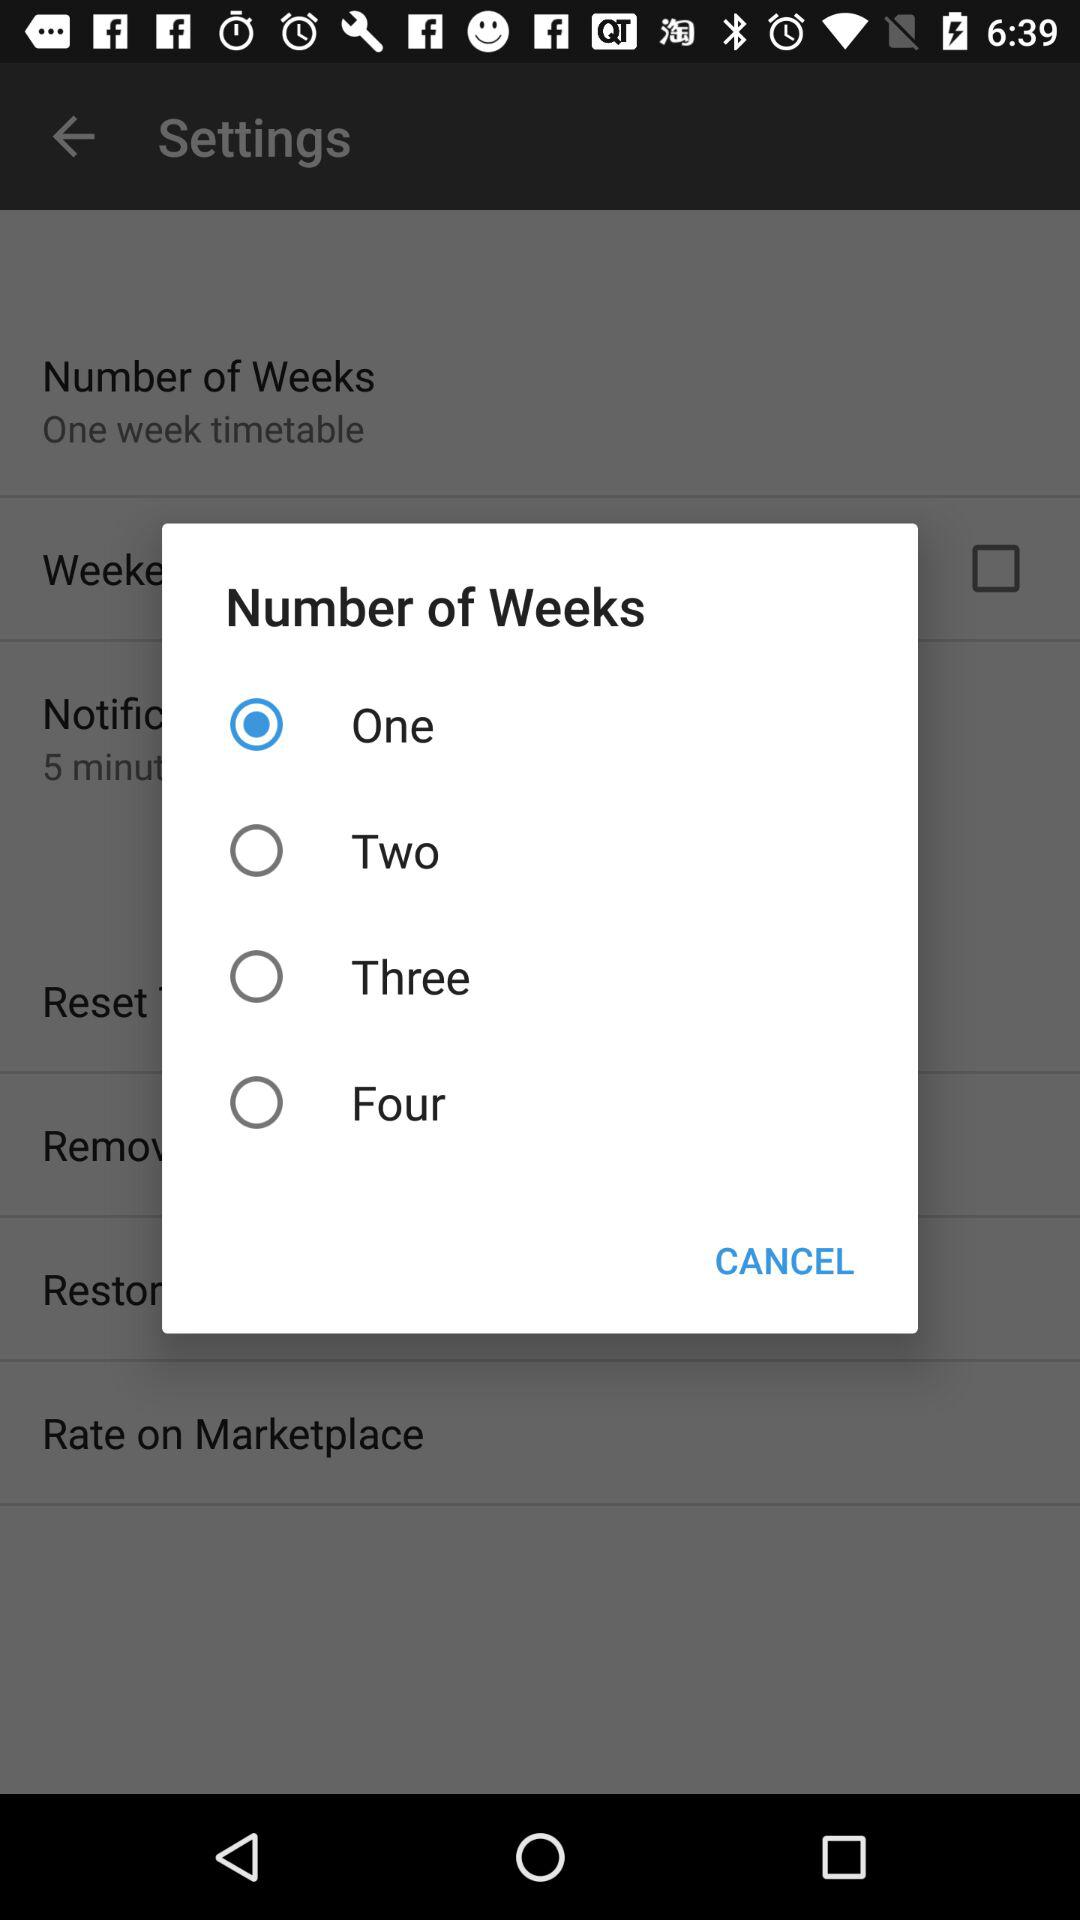What is the selected number of weeks? The selected number of weeks is one. 